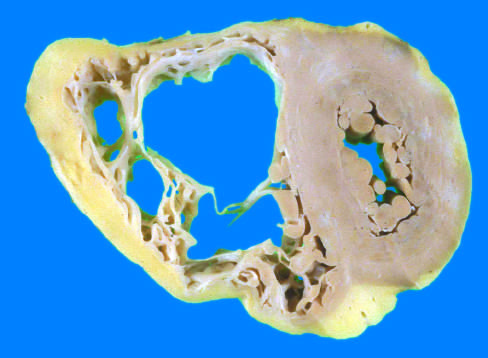what has a grossly normal appearance in this heart?
Answer the question using a single word or phrase. The left ventricle 